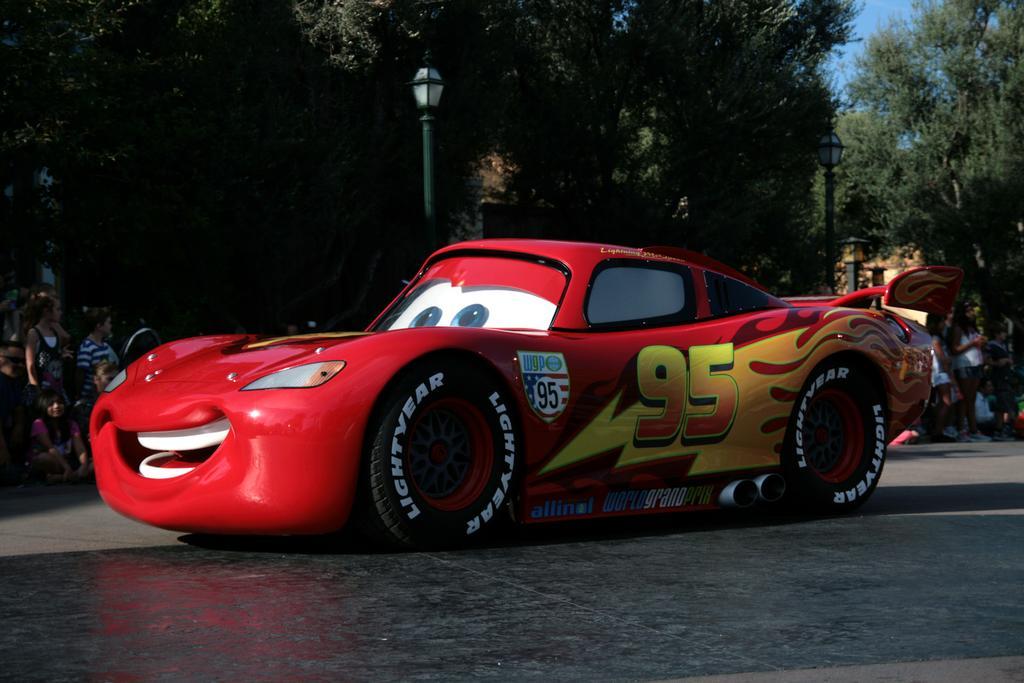Describe this image in one or two sentences. In the foreground of the picture there is a car. In the center of the picture there are people, trees and a street light. It is a sunny day. 